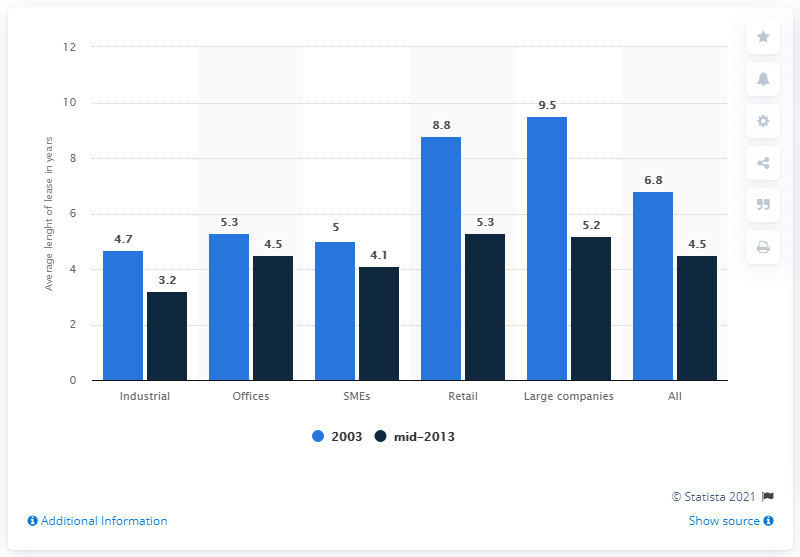Mention a couple of crucial points in this snapshot. In 2003, the revenues from offices were X, while in mid-2013, the revenues from offices were X + 0.8. Large companies have the highest average lease length. 